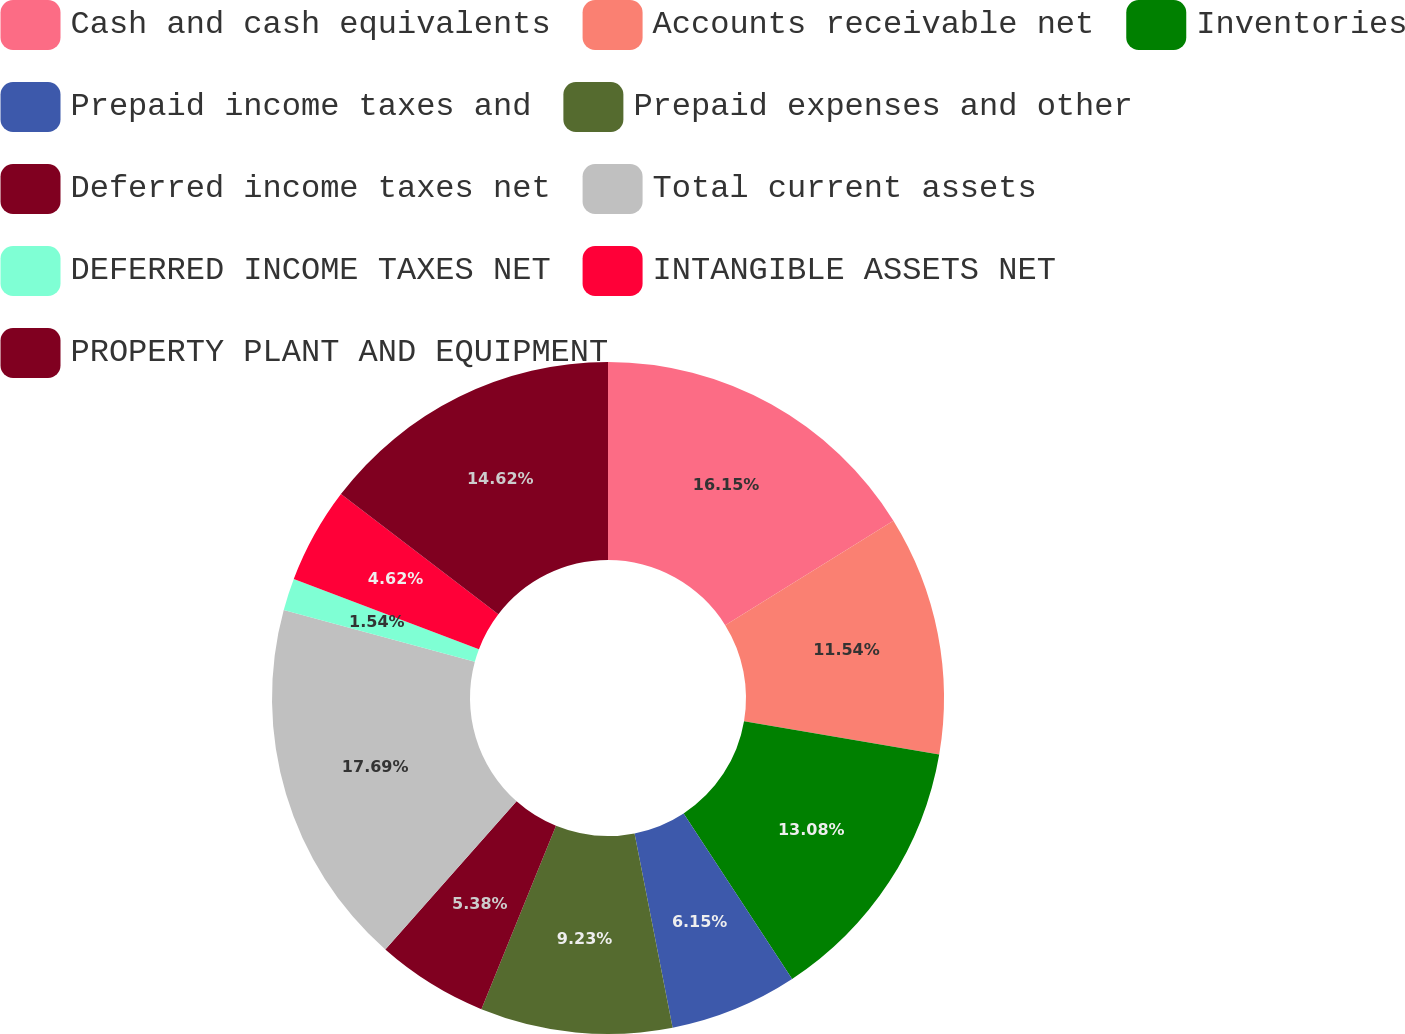Convert chart to OTSL. <chart><loc_0><loc_0><loc_500><loc_500><pie_chart><fcel>Cash and cash equivalents<fcel>Accounts receivable net<fcel>Inventories<fcel>Prepaid income taxes and<fcel>Prepaid expenses and other<fcel>Deferred income taxes net<fcel>Total current assets<fcel>DEFERRED INCOME TAXES NET<fcel>INTANGIBLE ASSETS NET<fcel>PROPERTY PLANT AND EQUIPMENT<nl><fcel>16.15%<fcel>11.54%<fcel>13.08%<fcel>6.15%<fcel>9.23%<fcel>5.38%<fcel>17.69%<fcel>1.54%<fcel>4.62%<fcel>14.62%<nl></chart> 